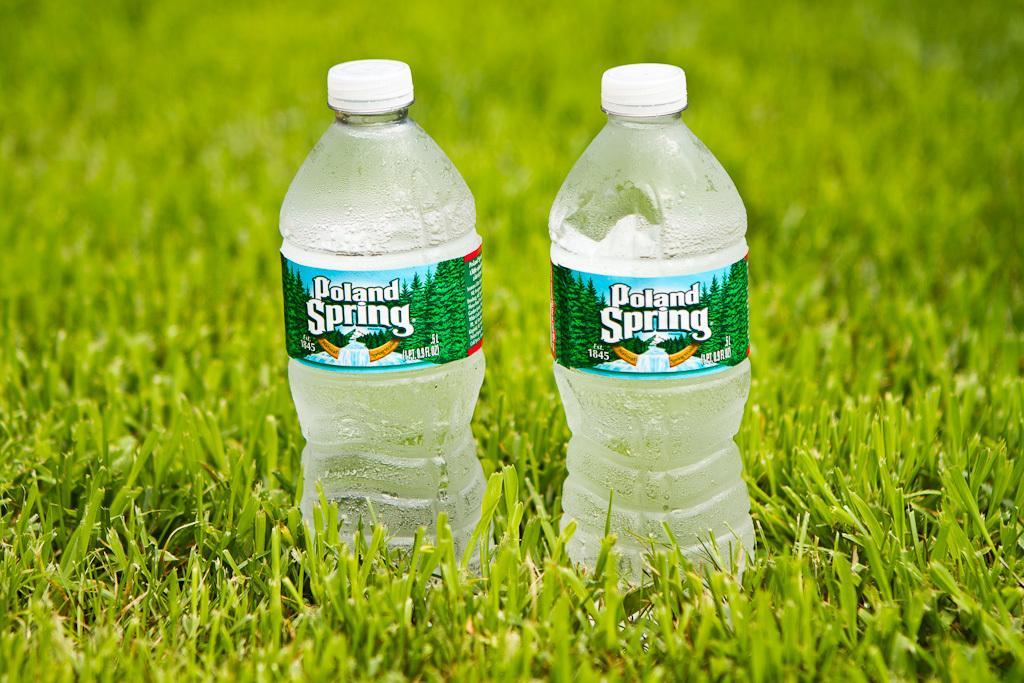How would you summarize this image in a sentence or two? As we can see in the image there is a grass and two bottles. 